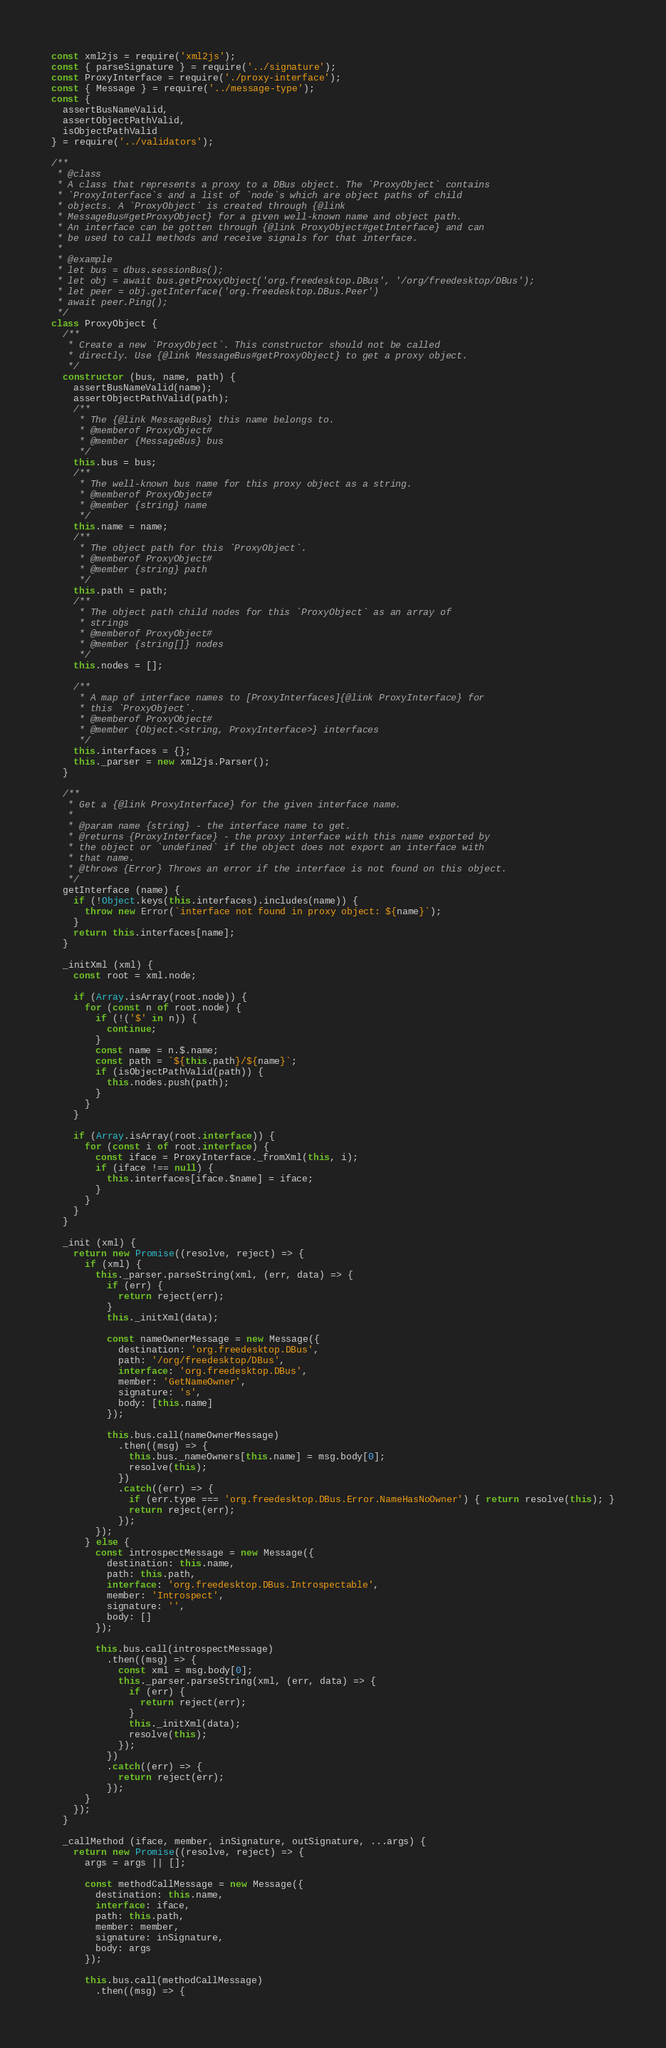Convert code to text. <code><loc_0><loc_0><loc_500><loc_500><_JavaScript_>const xml2js = require('xml2js');
const { parseSignature } = require('../signature');
const ProxyInterface = require('./proxy-interface');
const { Message } = require('../message-type');
const {
  assertBusNameValid,
  assertObjectPathValid,
  isObjectPathValid
} = require('../validators');

/**
 * @class
 * A class that represents a proxy to a DBus object. The `ProxyObject` contains
 * `ProxyInterface`s and a list of `node`s which are object paths of child
 * objects. A `ProxyObject` is created through {@link
 * MessageBus#getProxyObject} for a given well-known name and object path.
 * An interface can be gotten through {@link ProxyObject#getInterface} and can
 * be used to call methods and receive signals for that interface.
 *
 * @example
 * let bus = dbus.sessionBus();
 * let obj = await bus.getProxyObject('org.freedesktop.DBus', '/org/freedesktop/DBus');
 * let peer = obj.getInterface('org.freedesktop.DBus.Peer')
 * await peer.Ping();
 */
class ProxyObject {
  /**
   * Create a new `ProxyObject`. This constructor should not be called
   * directly. Use {@link MessageBus#getProxyObject} to get a proxy object.
   */
  constructor (bus, name, path) {
    assertBusNameValid(name);
    assertObjectPathValid(path);
    /**
     * The {@link MessageBus} this name belongs to.
     * @memberof ProxyObject#
     * @member {MessageBus} bus
     */
    this.bus = bus;
    /**
     * The well-known bus name for this proxy object as a string.
     * @memberof ProxyObject#
     * @member {string} name
     */
    this.name = name;
    /**
     * The object path for this `ProxyObject`.
     * @memberof ProxyObject#
     * @member {string} path
     */
    this.path = path;
    /**
     * The object path child nodes for this `ProxyObject` as an array of
     * strings
     * @memberof ProxyObject#
     * @member {string[]} nodes
     */
    this.nodes = [];

    /**
     * A map of interface names to [ProxyInterfaces]{@link ProxyInterface} for
     * this `ProxyObject`.
     * @memberof ProxyObject#
     * @member {Object.<string, ProxyInterface>} interfaces
     */
    this.interfaces = {};
    this._parser = new xml2js.Parser();
  }

  /**
   * Get a {@link ProxyInterface} for the given interface name.
   *
   * @param name {string} - the interface name to get.
   * @returns {ProxyInterface} - the proxy interface with this name exported by
   * the object or `undefined` if the object does not export an interface with
   * that name.
   * @throws {Error} Throws an error if the interface is not found on this object.
   */
  getInterface (name) {
    if (!Object.keys(this.interfaces).includes(name)) {
      throw new Error(`interface not found in proxy object: ${name}`);
    }
    return this.interfaces[name];
  }

  _initXml (xml) {
    const root = xml.node;

    if (Array.isArray(root.node)) {
      for (const n of root.node) {
        if (!('$' in n)) {
          continue;
        }
        const name = n.$.name;
        const path = `${this.path}/${name}`;
        if (isObjectPathValid(path)) {
          this.nodes.push(path);
        }
      }
    }

    if (Array.isArray(root.interface)) {
      for (const i of root.interface) {
        const iface = ProxyInterface._fromXml(this, i);
        if (iface !== null) {
          this.interfaces[iface.$name] = iface;
        }
      }
    }
  }

  _init (xml) {
    return new Promise((resolve, reject) => {
      if (xml) {
        this._parser.parseString(xml, (err, data) => {
          if (err) {
            return reject(err);
          }
          this._initXml(data);

          const nameOwnerMessage = new Message({
            destination: 'org.freedesktop.DBus',
            path: '/org/freedesktop/DBus',
            interface: 'org.freedesktop.DBus',
            member: 'GetNameOwner',
            signature: 's',
            body: [this.name]
          });

          this.bus.call(nameOwnerMessage)
            .then((msg) => {
              this.bus._nameOwners[this.name] = msg.body[0];
              resolve(this);
            })
            .catch((err) => {
              if (err.type === 'org.freedesktop.DBus.Error.NameHasNoOwner') { return resolve(this); }
              return reject(err);
            });
        });
      } else {
        const introspectMessage = new Message({
          destination: this.name,
          path: this.path,
          interface: 'org.freedesktop.DBus.Introspectable',
          member: 'Introspect',
          signature: '',
          body: []
        });

        this.bus.call(introspectMessage)
          .then((msg) => {
            const xml = msg.body[0];
            this._parser.parseString(xml, (err, data) => {
              if (err) {
                return reject(err);
              }
              this._initXml(data);
              resolve(this);
            });
          })
          .catch((err) => {
            return reject(err);
          });
      }
    });
  }

  _callMethod (iface, member, inSignature, outSignature, ...args) {
    return new Promise((resolve, reject) => {
      args = args || [];

      const methodCallMessage = new Message({
        destination: this.name,
        interface: iface,
        path: this.path,
        member: member,
        signature: inSignature,
        body: args
      });

      this.bus.call(methodCallMessage)
        .then((msg) => {</code> 